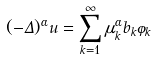<formula> <loc_0><loc_0><loc_500><loc_500>( - \Delta ) ^ { \alpha } u = \sum _ { k = 1 } ^ { \infty } \mu _ { k } ^ { \alpha } b _ { k } \varphi _ { k }</formula> 